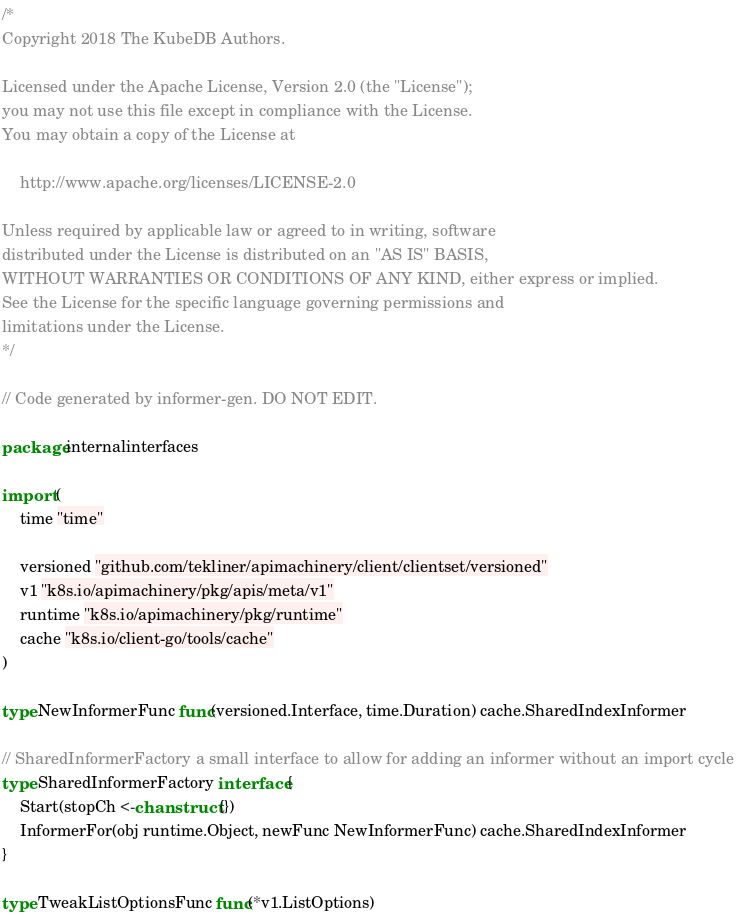<code> <loc_0><loc_0><loc_500><loc_500><_Go_>/*
Copyright 2018 The KubeDB Authors.

Licensed under the Apache License, Version 2.0 (the "License");
you may not use this file except in compliance with the License.
You may obtain a copy of the License at

    http://www.apache.org/licenses/LICENSE-2.0

Unless required by applicable law or agreed to in writing, software
distributed under the License is distributed on an "AS IS" BASIS,
WITHOUT WARRANTIES OR CONDITIONS OF ANY KIND, either express or implied.
See the License for the specific language governing permissions and
limitations under the License.
*/

// Code generated by informer-gen. DO NOT EDIT.

package internalinterfaces

import (
	time "time"

	versioned "github.com/tekliner/apimachinery/client/clientset/versioned"
	v1 "k8s.io/apimachinery/pkg/apis/meta/v1"
	runtime "k8s.io/apimachinery/pkg/runtime"
	cache "k8s.io/client-go/tools/cache"
)

type NewInformerFunc func(versioned.Interface, time.Duration) cache.SharedIndexInformer

// SharedInformerFactory a small interface to allow for adding an informer without an import cycle
type SharedInformerFactory interface {
	Start(stopCh <-chan struct{})
	InformerFor(obj runtime.Object, newFunc NewInformerFunc) cache.SharedIndexInformer
}

type TweakListOptionsFunc func(*v1.ListOptions)
</code> 